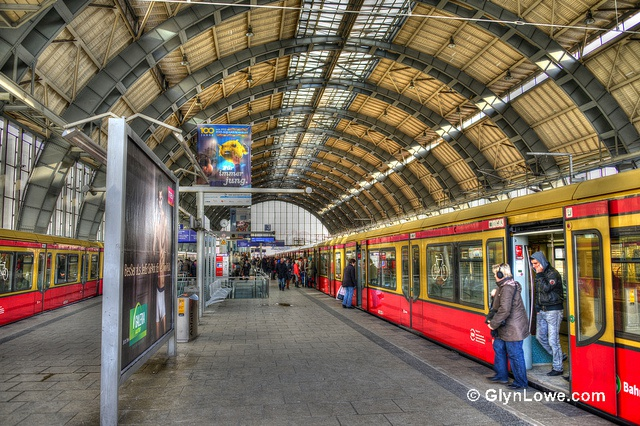Describe the objects in this image and their specific colors. I can see train in olive, red, black, and gray tones, train in olive, black, brown, and gray tones, people in olive, gray, navy, blue, and black tones, people in olive, black, gray, and darkgray tones, and people in olive, black, blue, gray, and navy tones in this image. 